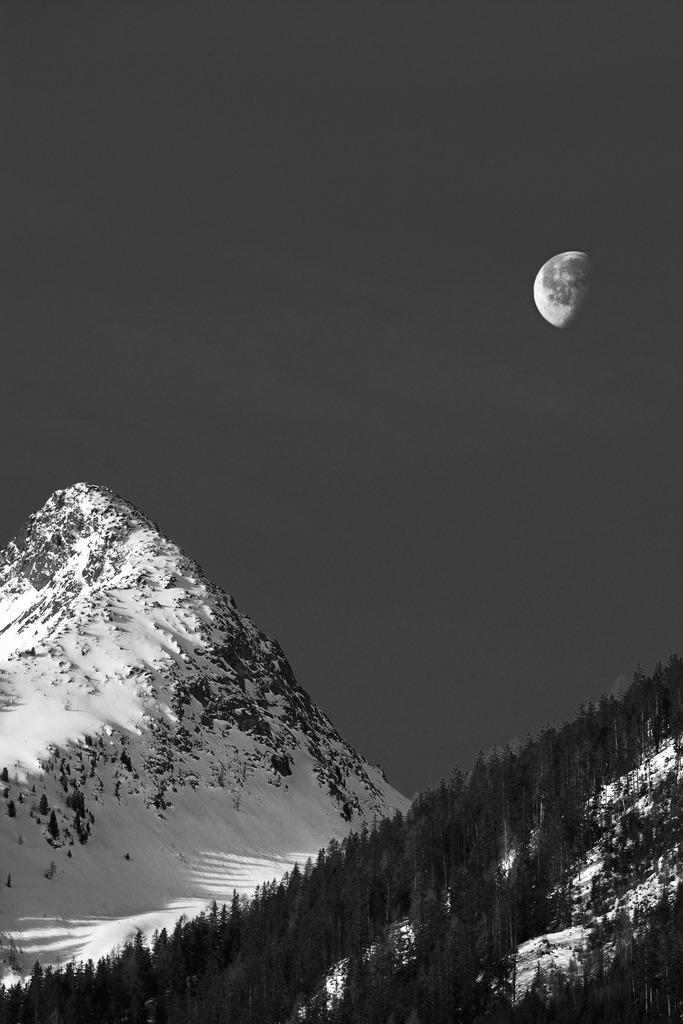What type of natural formation can be seen in the image? There are mountains in the image. What is covering the mountains? There is snow on the mountains. Are there any plants visible on the mountains? Yes, there are trees on the mountains. What can be seen in the background of the image? The sky is visible in the background of the image. What celestial body is visible in the sky? The moon is visible in the sky. What type of cream is being used to decorate the faces of the guests at the party in the image? There is no party or faces present in the image; it features mountains with snow and trees, as well as the sky and the moon. 